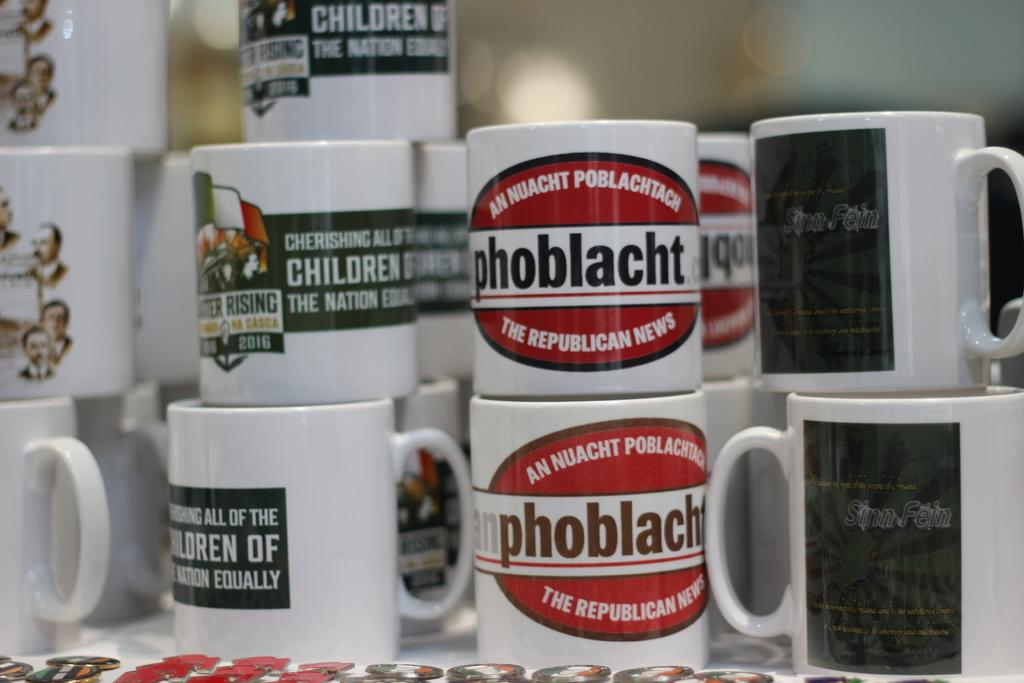<image>
Share a concise interpretation of the image provided. A white and red coffee mug advertises the Republican News. 